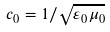Convert formula to latex. <formula><loc_0><loc_0><loc_500><loc_500>c _ { 0 } = 1 / { \sqrt { \varepsilon _ { 0 } \mu _ { 0 } } }</formula> 